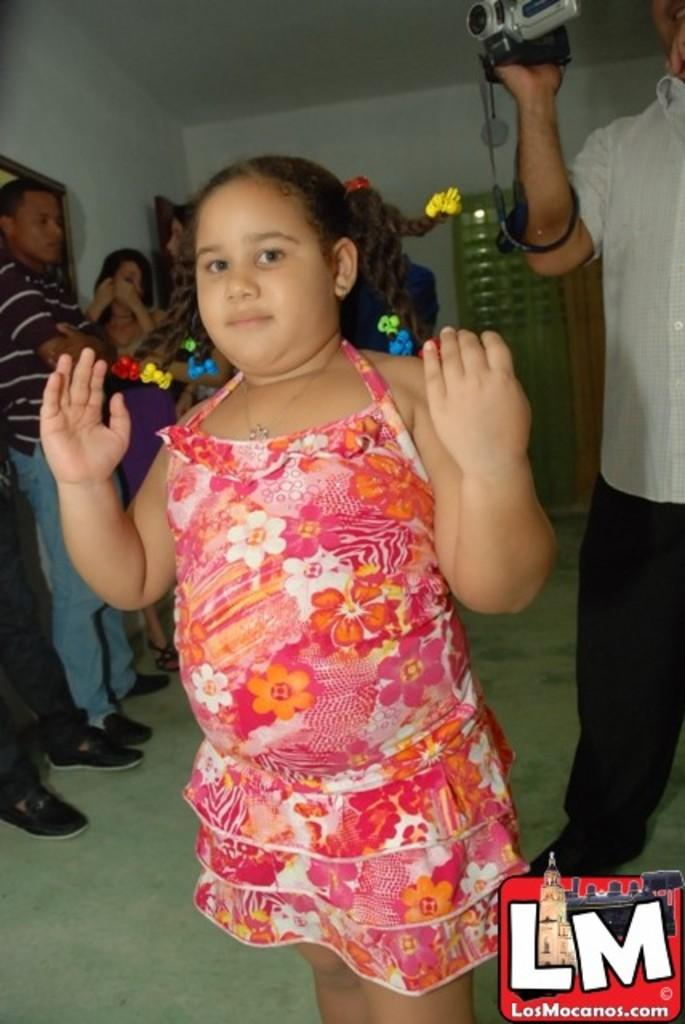How many people are in the image? There is a group of people in the image. What is the position of the people in the image? The people are standing on the floor. What can be seen at the bottom of the image? There is a logo at the bottom of the image. What is visible in the background of the image? There is a wall and a door in the background of the image. Where was the image taken? The image was taken in a hall. What type of pie is being served to the people in the image? There is no pie present in the image; it features a group of people standing in a hall. What is the people using to poke each other in the image? There is no stick or poking activity present in the image. 